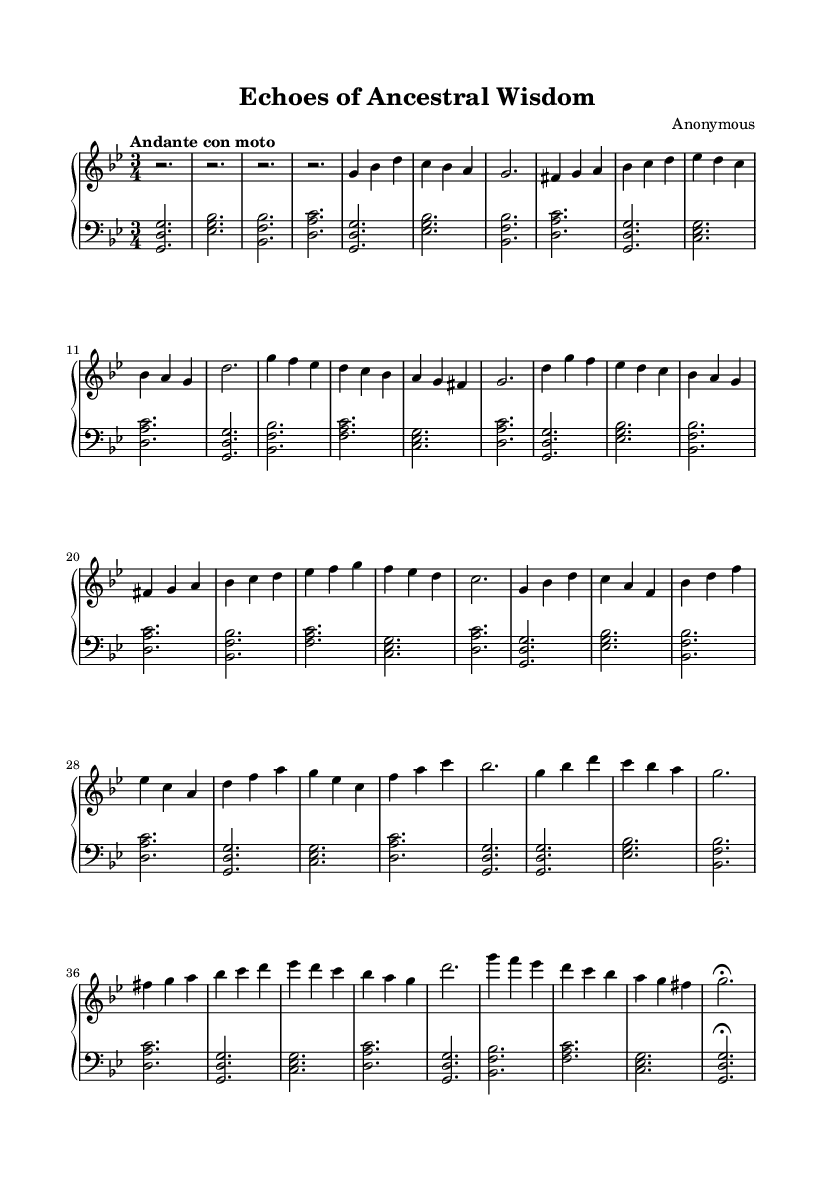What is the key signature of this music? The key signature can be found at the beginning of the staff, which shows two flats. This indicates the key is B flat major or G minor. In this case, the piece is in G minor.
Answer: G minor What is the time signature of this music? The time signature is indicated at the beginning of the piece as three beats per measure, represented by the 3/4 symbol at the start of the sheet music.
Answer: 3/4 What is the tempo marking for this composition? The tempo marking is written as "Andante con moto" at the beginning of the score, indicating a moderately slow pace with movement.
Answer: Andante con moto How many sections are in this piece? By analyzing the structure of the music, we can identify at least three distinct sections: Introduction, Theme A, and Theme B with a development part and a coda. Thus, there are five sections in total.
Answer: Five What musical form does this composition primarily follow? Observing the recurring themes within the piece, particularly Theme A and Theme B, along with the development and coda, we can deduce that it primarily follows a ternary or sonata form.
Answer: Ternary In which measure does Theme B first appear? Upon reviewing the score, Theme B can be identified starting at measure 9, which is where the melodic contour and harmony shifts distinctive from Theme A.
Answer: Measure 9 Which section indicates a return to Theme A after the development? Looking at the structure of the piece, Theme A returns after the development section in Theme A' as indicated in the repeated phrases.
Answer: Theme A' 